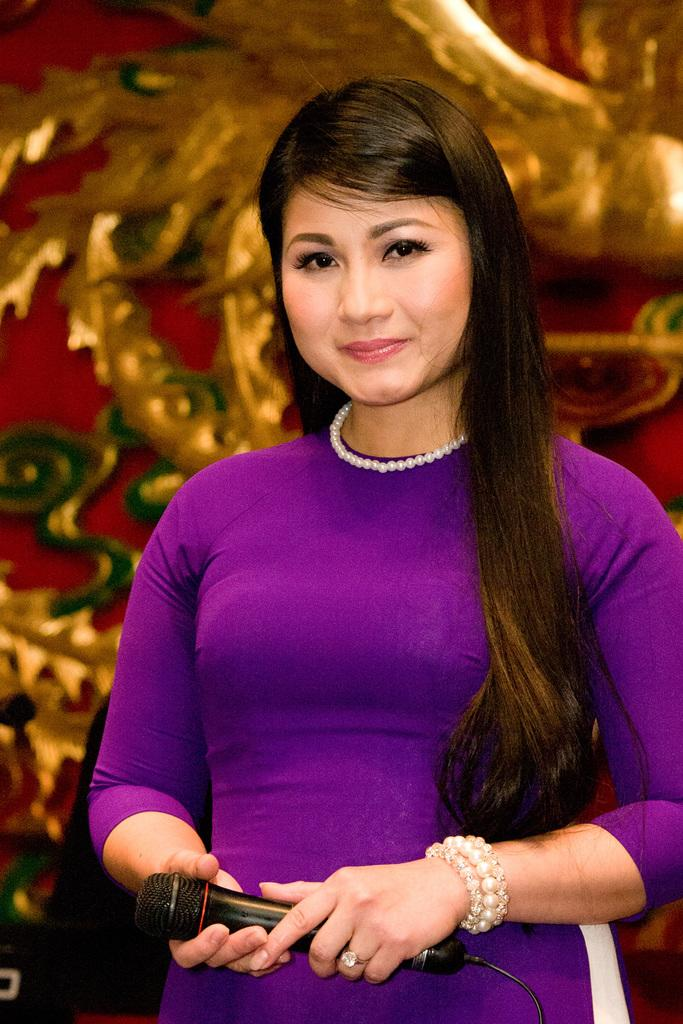Who is the main subject in the image? There is a woman in the image. What is the woman doing in the image? The woman is standing and smiling. What object is the woman holding in her hand? The woman is holding a microphone in her hand. How many pizzas can be seen in the image? There are no pizzas present in the image. What type of feeling does the woman appear to be experiencing in the image? The woman is smiling, which suggests a positive feeling, but we cannot determine the exact feeling from the image alone. 